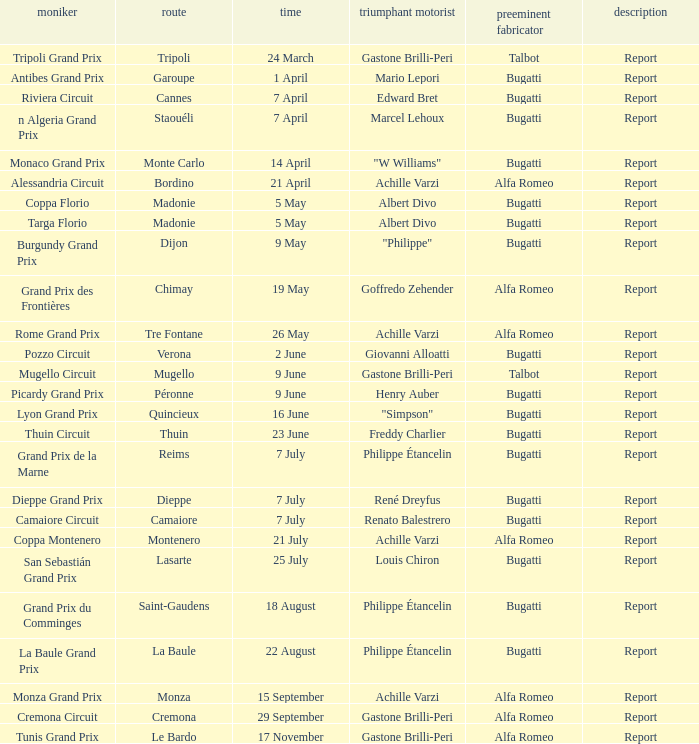What Winning driver has a Winning constructor of talbot? Gastone Brilli-Peri, Gastone Brilli-Peri. 